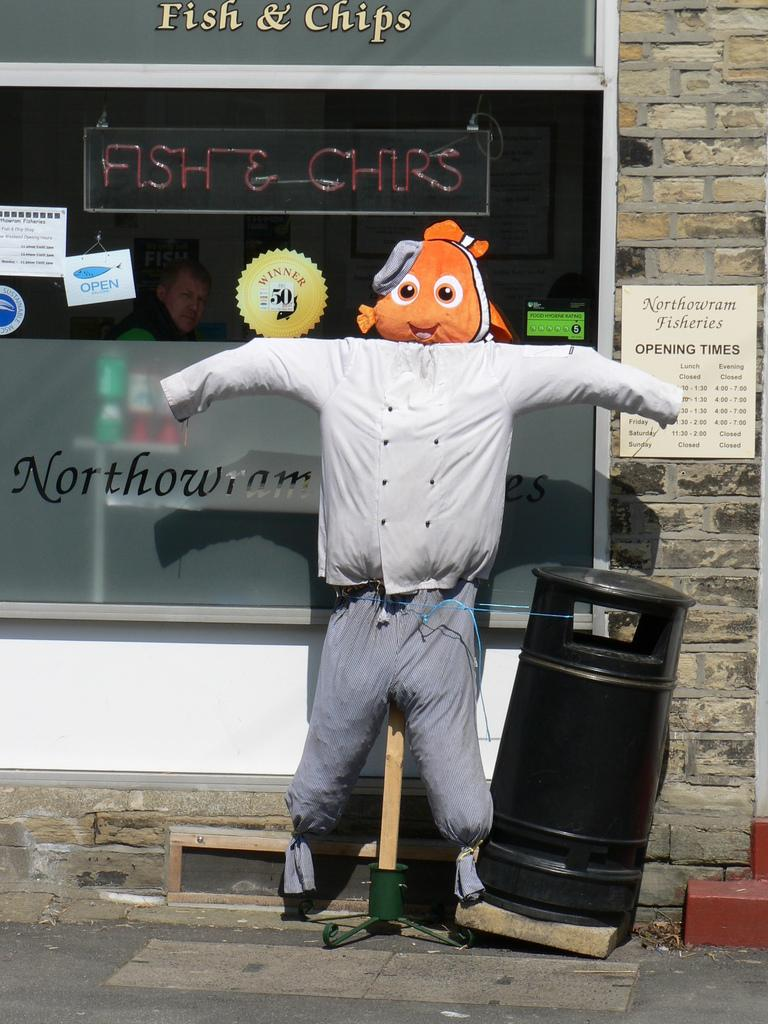<image>
Give a short and clear explanation of the subsequent image. Stuffed doll of a human next to a sign that tells the Opening Times. 